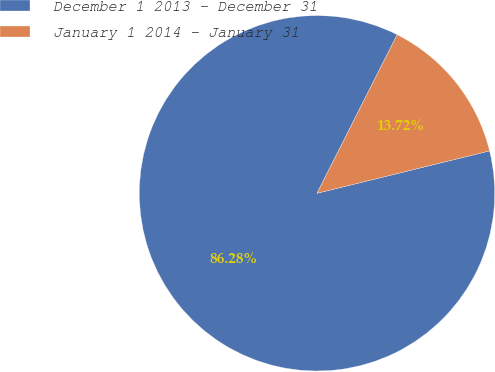Convert chart to OTSL. <chart><loc_0><loc_0><loc_500><loc_500><pie_chart><fcel>December 1 2013 - December 31<fcel>January 1 2014 - January 31<nl><fcel>86.28%<fcel>13.72%<nl></chart> 